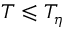Convert formula to latex. <formula><loc_0><loc_0><loc_500><loc_500>T \leqslant T _ { \eta }</formula> 